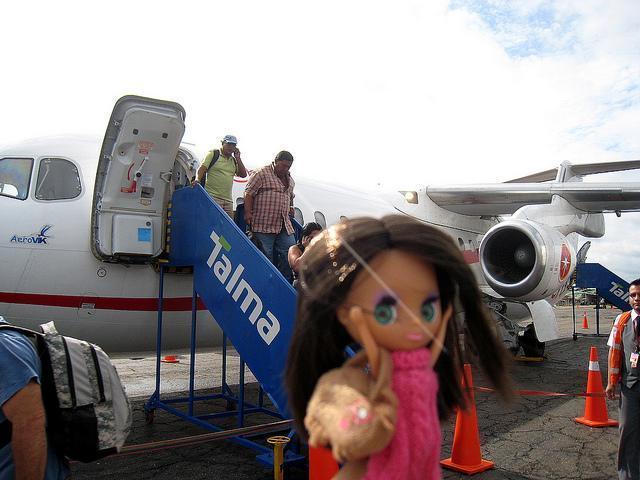How many full cones are viewable?
Give a very brief answer. 3. How many people are visible?
Give a very brief answer. 4. How many rolls of toilet paper is there?
Give a very brief answer. 0. 